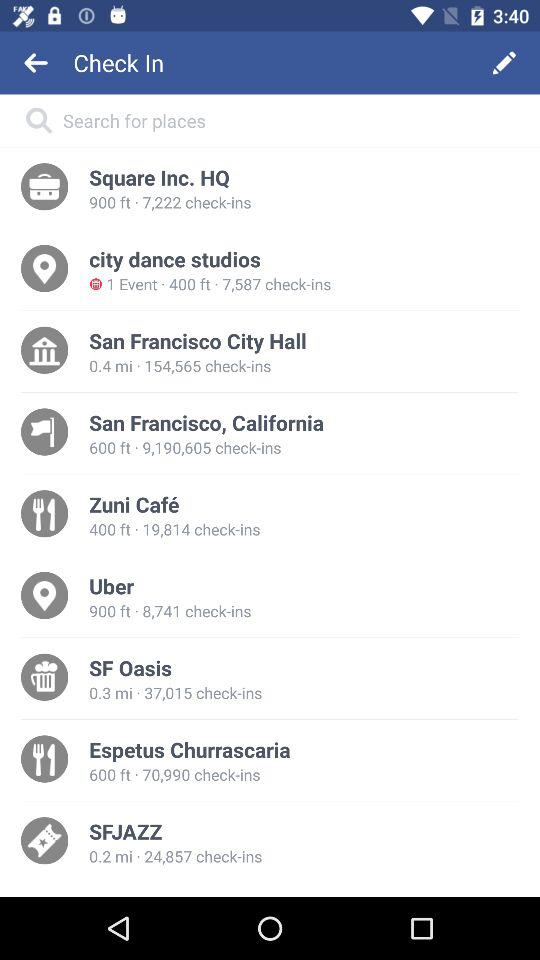Which location is at 600 ft and has 9,190,606 check-ins? The location is San Francisco, California. 